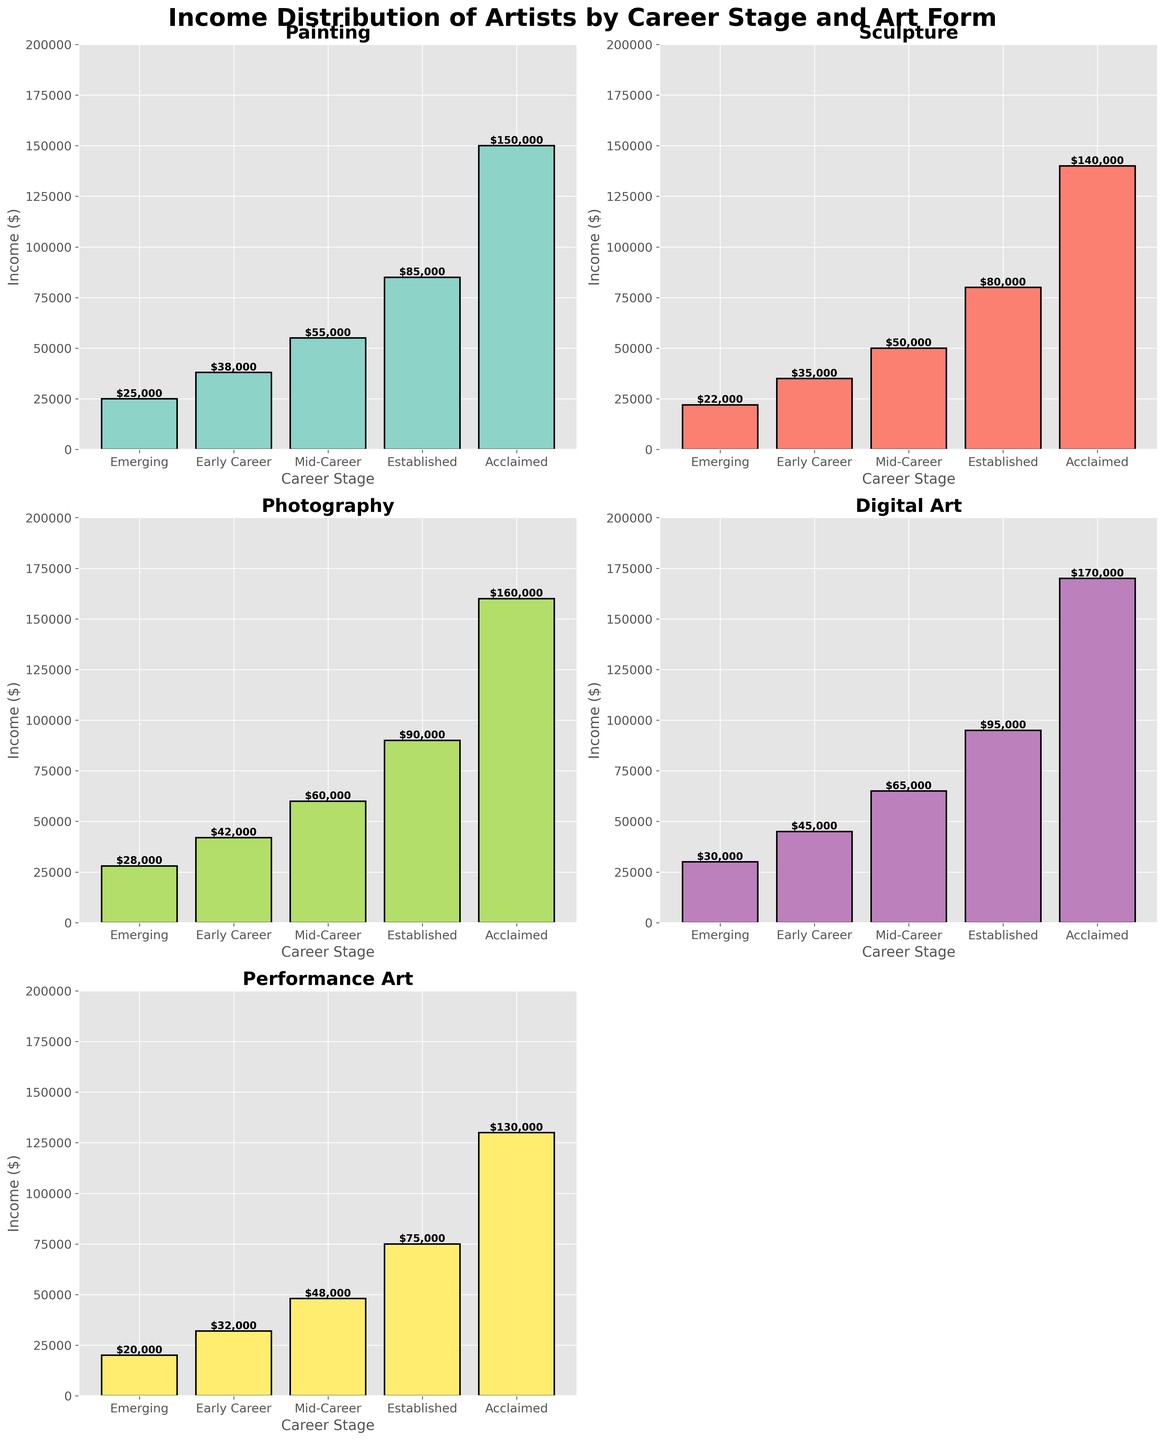What is the income difference between mid-career and early career artists in Digital Art? To find the income difference, first identify the incomes for mid-career and early career artists in Digital Art, which are $65,000 and $45,000 respectively. Then subtract the early career income from the mid-career income: $65,000 - $45,000 = $20,000.
Answer: $20,000 Which art form has the highest income for emerging artists? Check the income values for emerging artists in each art form. The values are: Painting: $25,000, Sculpture: $22,000, Photography: $28,000, Digital Art: $30,000, Performance Art: $20,000. Digital Art has the highest income of $30,000.
Answer: Digital Art Comparing established artists, which art form shows the smallest income? Identify the incomes for established artists across all art forms: Painting: $85,000, Sculpture: $80,000, Photography: $90,000, Digital Art: $95,000, Performance Art: $75,000. Performance Art has the smallest income of $75,000.
Answer: Performance Art What is the average income for mid-career artists across all art forms? Calculate the average by adding the incomes of mid-career artists in all art forms and dividing by the number of art forms. The incomes are: Painting: $55,000, Sculpture: $50,000, Photography: $60,000, Digital Art: $65,000, Performance Art: $48,000. Sum: $55,000 + $50,000 + $60,000 + $65,000 + $48,000 = $278,000. Average: $278,000 / 5 = $55,600.
Answer: $55,600 Is the income for acclaimed artists in Photography higher than the income for established artists in Painting? Check the incomes of acclaimed artists in Photography and established artists in Painting. The values are: Photography: $160,000, Painting: $85,000. Since $160,000 is greater than $85,000, the income for acclaimed artists in Photography is higher.
Answer: Yes How much more does an acclaimed artist in Digital Art make compared to a mid-career artist in the same field? Identify the incomes for acclaimed and mid-career artists in Digital Art, which are $170,000 and $65,000 respectively. Subtract the mid-career income from the acclaimed income: $170,000 - $65,000 = $105,000.
Answer: $105,000 Which career stage has the lowest income in Performance Art and what is that income? Inspect the incomes in Performance Art across all career stages. The values are: Emerging: $20,000, Early Career: $32,000, Mid-Career: $48,000, Established: $75,000, Acclaimed: $130,000. The lowest income is $20,000 at the Emerging stage.
Answer: Emerging, $20,000 What is the difference in income between established and acclaimed artists in Sculpture? Identify the incomes for established and acclaimed artists in Sculpture, which are $80,000 and $140,000 respectively. Then subtract the established income from the acclaimed income: $140,000 - $80,000 = $60,000.
Answer: $60,000 